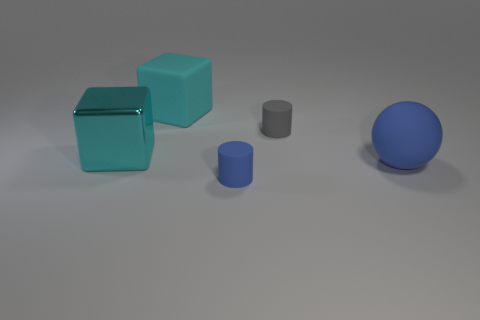Add 1 matte cubes. How many objects exist? 6 Subtract all cylinders. How many objects are left? 3 Add 4 large green shiny cylinders. How many large green shiny cylinders exist? 4 Subtract 0 green cylinders. How many objects are left? 5 Subtract all purple rubber spheres. Subtract all large blue matte things. How many objects are left? 4 Add 3 big blocks. How many big blocks are left? 5 